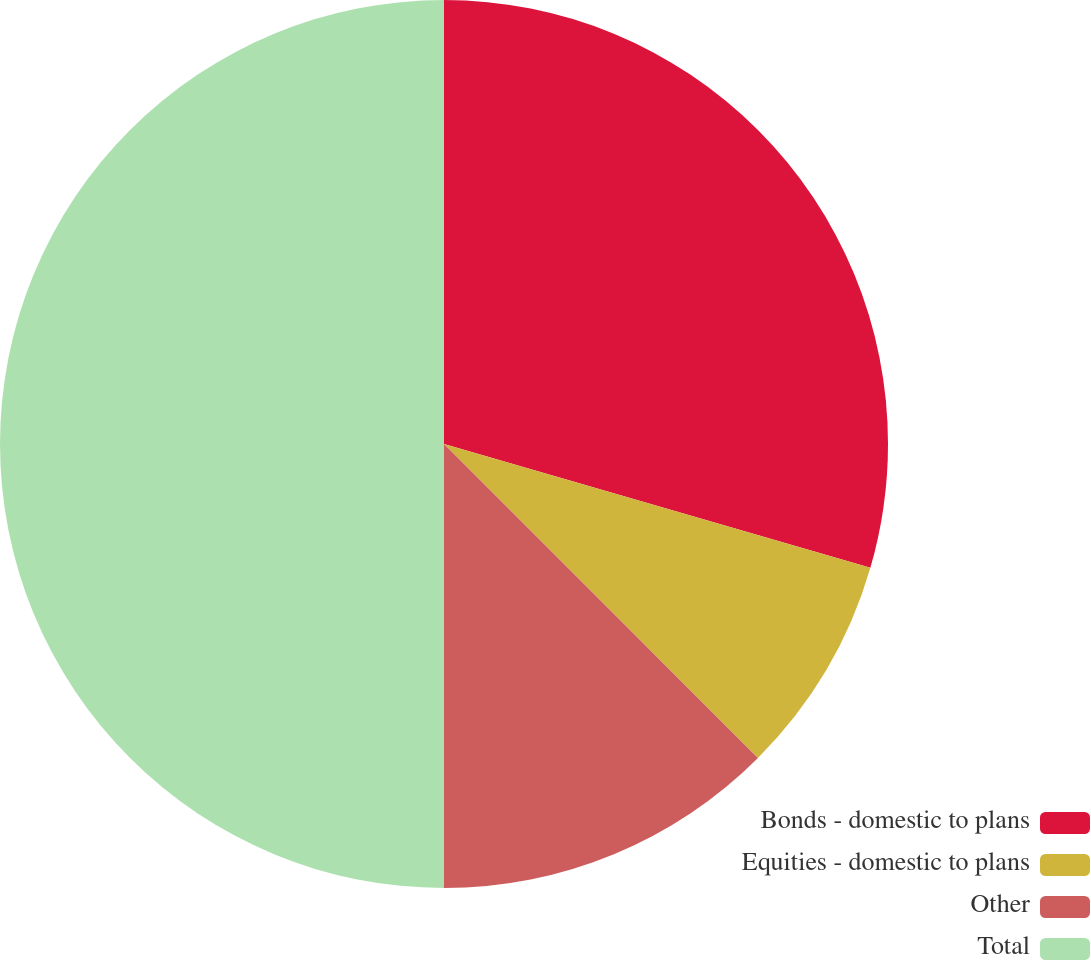<chart> <loc_0><loc_0><loc_500><loc_500><pie_chart><fcel>Bonds - domestic to plans<fcel>Equities - domestic to plans<fcel>Other<fcel>Total<nl><fcel>29.5%<fcel>8.0%<fcel>12.5%<fcel>50.0%<nl></chart> 